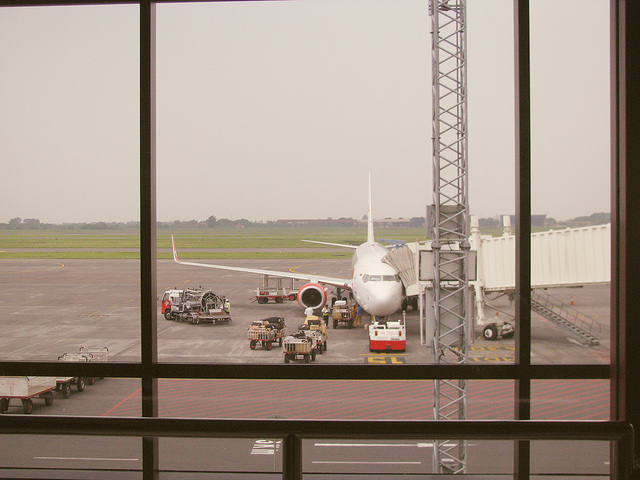<image>What time is it? It is unknown what time it is. It can be morning, day time, afternoon or even specific time 2pm. Which parking space pictured is empty? It is ambiguous which parking space is empty. It could be the left or front space. What time is it? I don't know what time it is. It can be morning, daytime, 2pm or afternoon. Which parking space pictured is empty? There is no empty parking space pictured. 